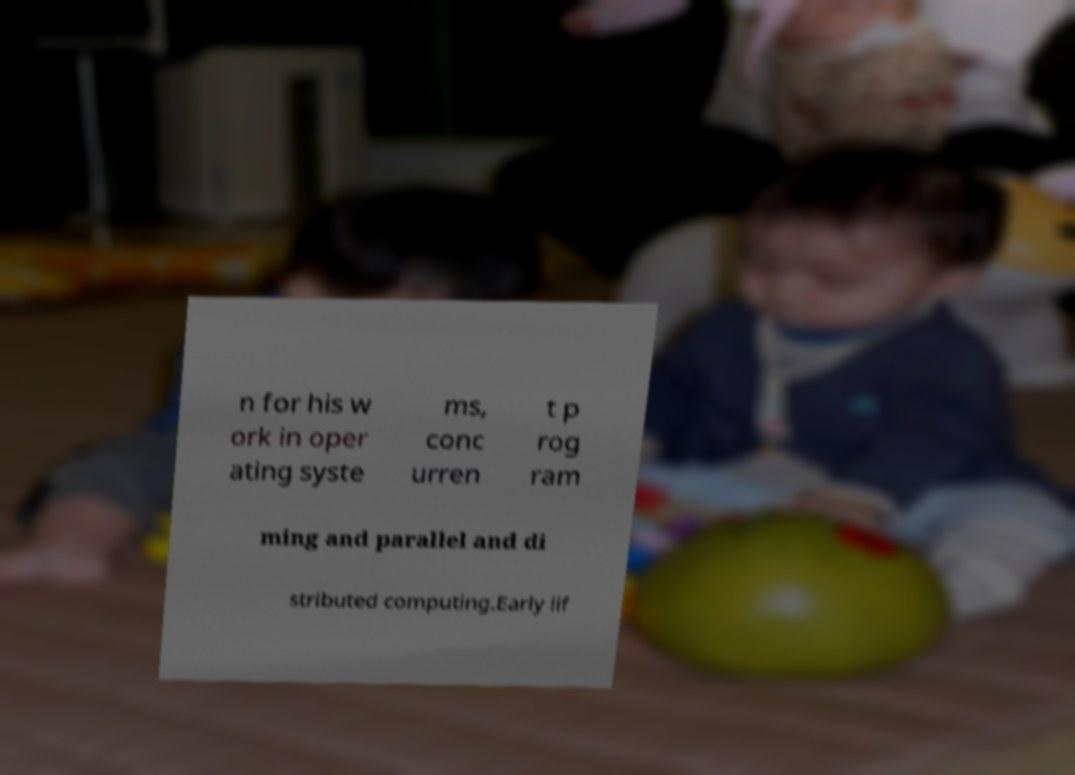Can you read and provide the text displayed in the image?This photo seems to have some interesting text. Can you extract and type it out for me? n for his w ork in oper ating syste ms, conc urren t p rog ram ming and parallel and di stributed computing.Early lif 